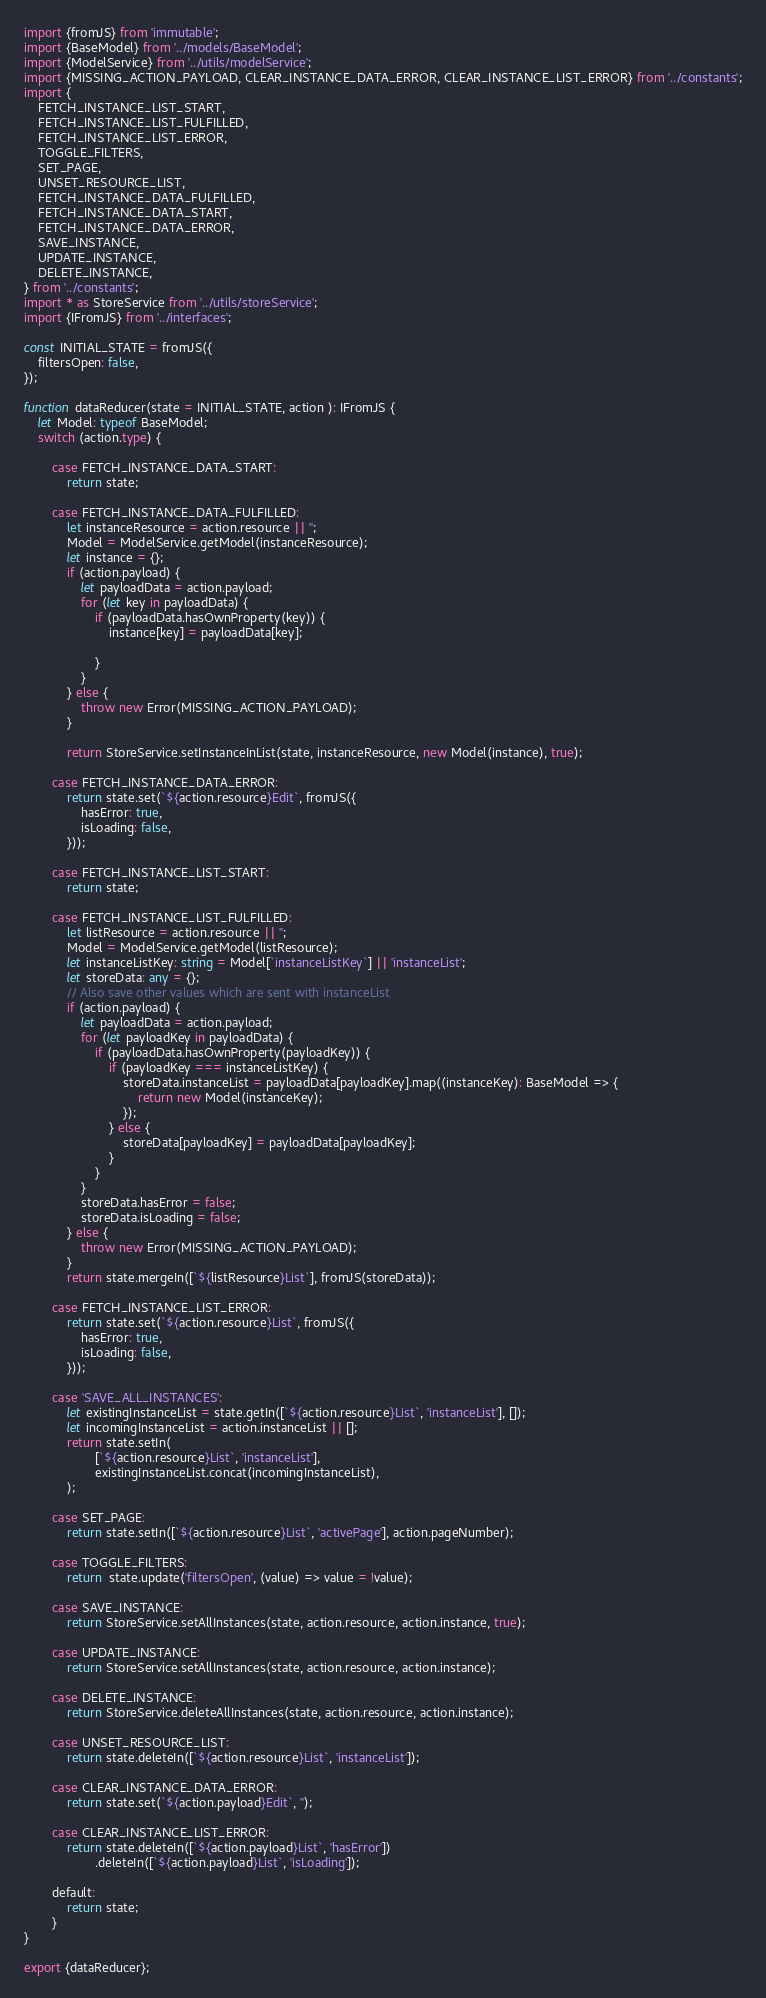Convert code to text. <code><loc_0><loc_0><loc_500><loc_500><_TypeScript_>import {fromJS} from 'immutable';
import {BaseModel} from '../models/BaseModel';
import {ModelService} from '../utils/modelService';
import {MISSING_ACTION_PAYLOAD, CLEAR_INSTANCE_DATA_ERROR, CLEAR_INSTANCE_LIST_ERROR} from '../constants';
import {
    FETCH_INSTANCE_LIST_START,
    FETCH_INSTANCE_LIST_FULFILLED,
    FETCH_INSTANCE_LIST_ERROR,
    TOGGLE_FILTERS,
    SET_PAGE,
    UNSET_RESOURCE_LIST,
    FETCH_INSTANCE_DATA_FULFILLED,
    FETCH_INSTANCE_DATA_START,
    FETCH_INSTANCE_DATA_ERROR,
    SAVE_INSTANCE,
    UPDATE_INSTANCE,
    DELETE_INSTANCE,
} from '../constants';
import * as StoreService from '../utils/storeService';
import {IFromJS} from '../interfaces';

const INITIAL_STATE = fromJS({
    filtersOpen: false,
});

function dataReducer(state = INITIAL_STATE, action ): IFromJS {
    let Model: typeof BaseModel;
    switch (action.type) {

        case FETCH_INSTANCE_DATA_START:
            return state;

        case FETCH_INSTANCE_DATA_FULFILLED:
            let instanceResource = action.resource || '';
            Model = ModelService.getModel(instanceResource);
            let instance = {};
            if (action.payload) {
                let payloadData = action.payload;
                for (let key in payloadData) {
                    if (payloadData.hasOwnProperty(key)) {
                        instance[key] = payloadData[key];

                    }
                }
            } else {
                throw new Error(MISSING_ACTION_PAYLOAD);
            }

            return StoreService.setInstanceInList(state, instanceResource, new Model(instance), true);

        case FETCH_INSTANCE_DATA_ERROR:
            return state.set(`${action.resource}Edit`, fromJS({
                hasError: true,
                isLoading: false,
            }));

        case FETCH_INSTANCE_LIST_START:
            return state;

        case FETCH_INSTANCE_LIST_FULFILLED:
            let listResource = action.resource || '';
            Model = ModelService.getModel(listResource);
            let instanceListKey: string = Model[`instanceListKey`] || 'instanceList';
            let storeData: any = {};
            // Also save other values which are sent with instanceList
            if (action.payload) {
                let payloadData = action.payload;
                for (let payloadKey in payloadData) {
                    if (payloadData.hasOwnProperty(payloadKey)) {
                        if (payloadKey === instanceListKey) {
                            storeData.instanceList = payloadData[payloadKey].map((instanceKey): BaseModel => {
                                return new Model(instanceKey);
                            });
                        } else {
                            storeData[payloadKey] = payloadData[payloadKey];
                        }
                    }
                }
                storeData.hasError = false;
                storeData.isLoading = false;
            } else {
                throw new Error(MISSING_ACTION_PAYLOAD);
            }
            return state.mergeIn([`${listResource}List`], fromJS(storeData));

        case FETCH_INSTANCE_LIST_ERROR:
            return state.set(`${action.resource}List`, fromJS({
                hasError: true,
                isLoading: false,
            }));

        case 'SAVE_ALL_INSTANCES':
            let existingInstanceList = state.getIn([`${action.resource}List`, 'instanceList'], []);
            let incomingInstanceList = action.instanceList || [];
            return state.setIn(
                    [`${action.resource}List`, 'instanceList'],
                    existingInstanceList.concat(incomingInstanceList),
            );

        case SET_PAGE:
            return state.setIn([`${action.resource}List`, 'activePage'], action.pageNumber);

        case TOGGLE_FILTERS:
            return  state.update('filtersOpen', (value) => value = !value);

        case SAVE_INSTANCE:
            return StoreService.setAllInstances(state, action.resource, action.instance, true);

        case UPDATE_INSTANCE:
            return StoreService.setAllInstances(state, action.resource, action.instance);

        case DELETE_INSTANCE:
            return StoreService.deleteAllInstances(state, action.resource, action.instance);

        case UNSET_RESOURCE_LIST:
            return state.deleteIn([`${action.resource}List`, 'instanceList']);

        case CLEAR_INSTANCE_DATA_ERROR:
            return state.set(`${action.payload}Edit`, '');

        case CLEAR_INSTANCE_LIST_ERROR:
            return state.deleteIn([`${action.payload}List`, 'hasError'])
                    .deleteIn([`${action.payload}List`, 'isLoading']);

        default:
            return state;
        }
}

export {dataReducer};
</code> 